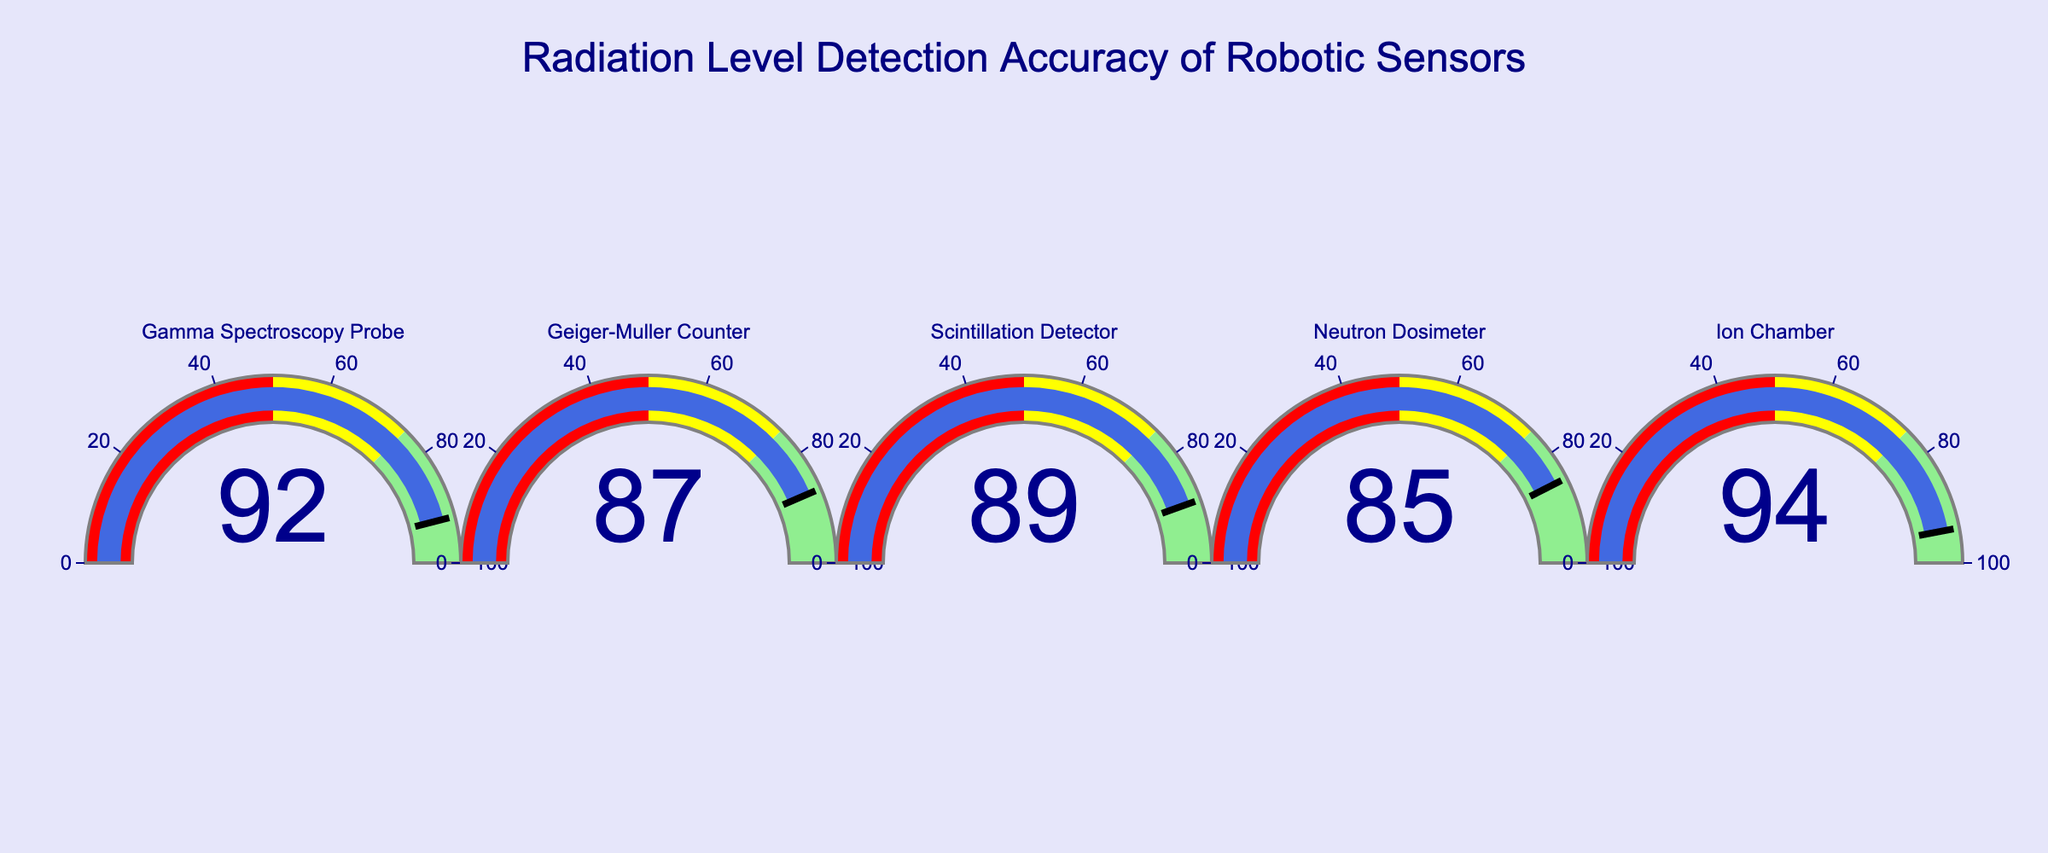What is the accuracy percentage of the Ion Chamber sensor? Look at the gauge for the Ion Chamber; the displayed number is the accuracy percentage.
Answer: 94 Which sensor has the highest accuracy percentage? Compare the displayed numbers on each gauge to identify the highest value.
Answer: Ion Chamber What is the average accuracy of all the sensors combined? Add all the accuracy percentages and divide by the number of sensors. \( \frac{92 + 87 + 89 + 85 + 94}{5} = 89.4 \)
Answer: 89.4 What is the difference in accuracy between the Gamma Spectroscopy Probe and the Geiger-Muller Counter? Subtract the accuracy percentage of the Geiger-Muller Counter from that of the Gamma Spectroscopy Probe. \( 92 - 87 = 5 \)
Answer: 5 Which sensor has an accuracy percentage below 90%? Identify the gauges with accuracy percentages below 90%.
Answer: Geiger-Muller Counter, Scintillation Detector, Neutron Dosimeter How many sensors have an accuracy percentage above 90%? Count the number of sensors with accuracy percentages above 90%.
Answer: 2 List the sensors' accuracy in descending order. Arrange the accuracy percentages from highest to lowest and list the corresponding sensors.
Answer: Ion Chamber (94), Gamma Spectroscopy Probe (92), Scintillation Detector (89), Geiger-Muller Counter (87), Neutron Dosimeter (85) What is the combined accuracy of the Gamma Spectroscopy Probe and the Ion Chamber? Add the accuracy percentages of both sensors. \( 92 + 94 = 186 \)
Answer: 186 Which sensors fall into the light green color range (accuracy between 75 and 100)? Identify the sensors with percentages within the 75-100 range indicated by the light green color.
Answer: All sensors 